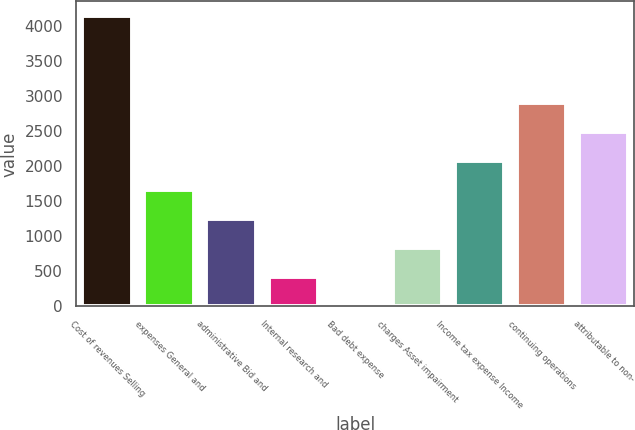Convert chart. <chart><loc_0><loc_0><loc_500><loc_500><bar_chart><fcel>Cost of revenues Selling<fcel>expenses General and<fcel>administrative Bid and<fcel>Internal research and<fcel>Bad debt expense<fcel>charges Asset impairment<fcel>Income tax expense Income<fcel>continuing operations<fcel>attributable to non-<nl><fcel>4146<fcel>1663.2<fcel>1249.4<fcel>421.8<fcel>8<fcel>835.6<fcel>2077<fcel>2904.6<fcel>2490.8<nl></chart> 